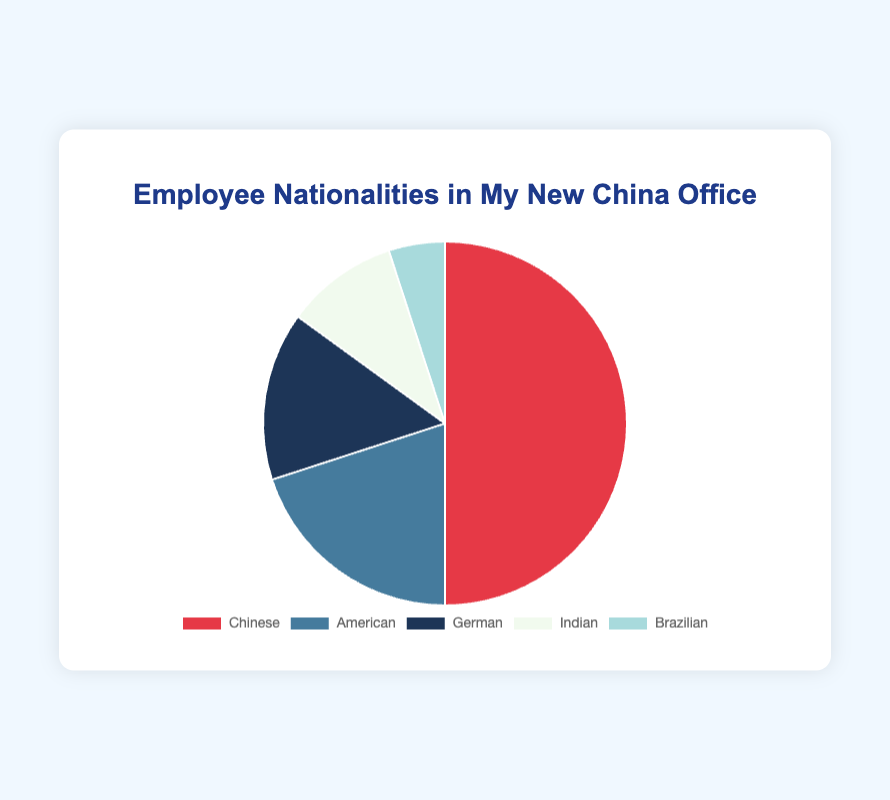What percentage of employees in the office are Chinese? The chart shows that the Chinese employees form the largest slice, labelled with the percentage 50%.
Answer: 50% How many nationalities are represented in the office? By counting the distinct slices and their labels in the pie chart, we can determine there are five nationalities represented.
Answer: 5 Which nationality has the second largest percentage of employees, and what is that percentage? The pie chart shows the American nationality with a 20% slice, making it the second largest.
Answer: American, 20% Compare the combined percentage of German and Indian employees to the percentage of American employees. The combined percentage of German (15%) and Indian (10%) employees is 25%, which is greater than the American percentage of 20%.
Answer: 25% > 20% What is the combined percentage of employees who are either Brazilian or German? Adding the percentages of Brazilian (5%) and German (15%) employees results in 20%.
Answer: 20% Which slices in the pie chart are the smallest, and what are their respective colors? The smallest slice represents Brazilian employees at 5%, which is colored in a shade of teal.
Answer: Brazilian, teal Is the percentage of Chinese employees more than double that of Indian employees? The percentage of Chinese employees is 50%, and the percentage of Indian employees is 10%. Since 50% is indeed more than double 10%, the statement is true.
Answer: Yes, 50% > 2 * 10% What is the total percentage of non-Chinese employees in the office? Adding up all the non-Chinese employee percentages: American (20%), German (15%), Indian (10%), Brazilian (5%) gives a total of 50%.
Answer: 50% Are there more American or German employees, and by what percentage difference? The chart shows 20% American employees and 15% German employees, so the difference is 5%.
Answer: American, 5% more 